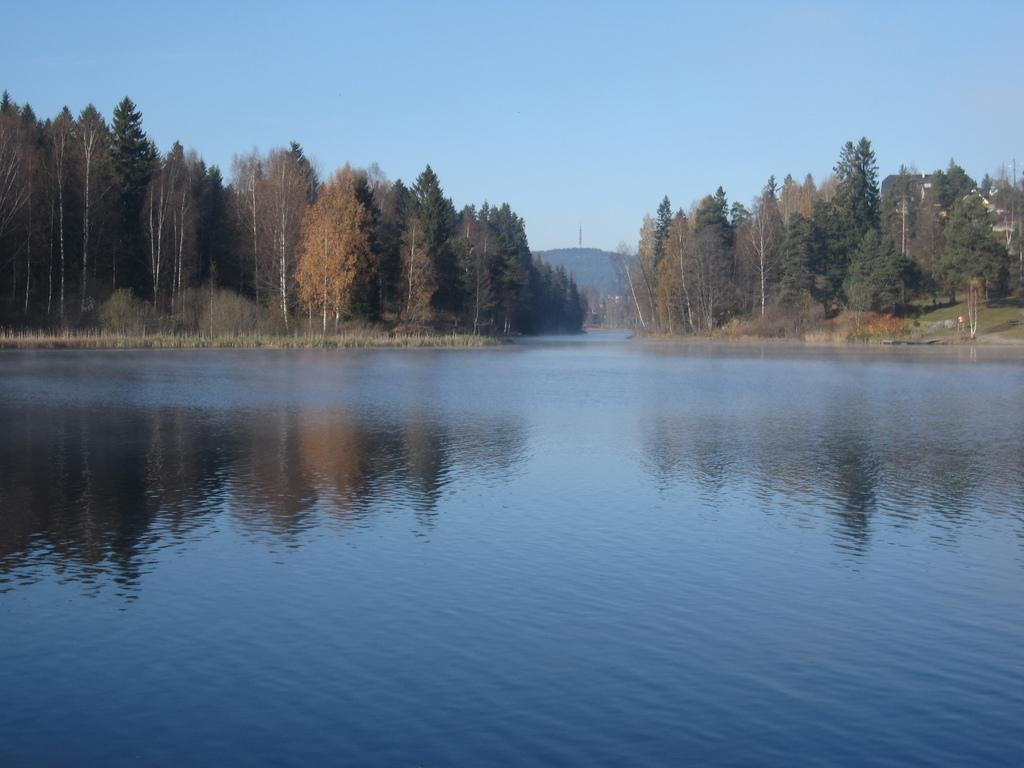What type of natural landscape can be seen in the image? There are hills, trees, bushes, grass, and a lake visible in the image. What can be found in the sky in the image? The sky is visible in the image. What type of vegetation is present in the image? Trees, bushes, and grass are present in the image. What type of creature is hosting a party in the image? There is no creature or party present in the image. Can you describe the frog's role in the image? There is no frog present in the image. 